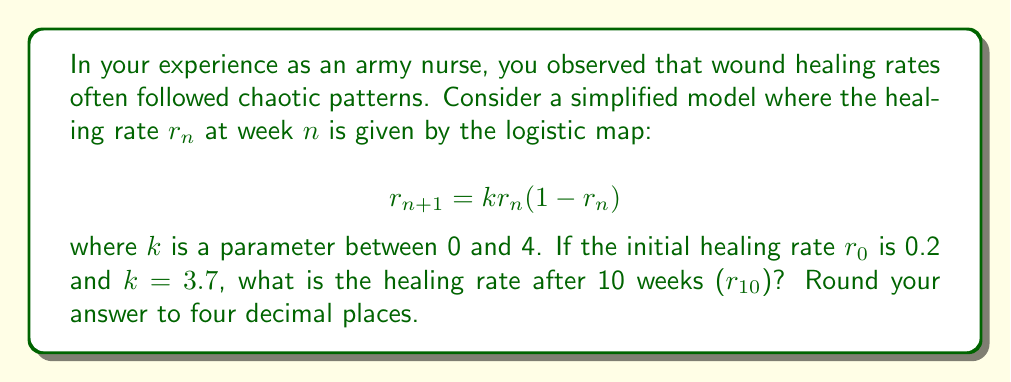Can you answer this question? To solve this problem, we need to iterate the logistic map equation 10 times, starting with $r_0 = 0.2$ and using $k = 3.7$. Let's calculate step-by-step:

1) $r_1 = 3.7 \cdot 0.2 \cdot (1-0.2) = 0.592$

2) $r_2 = 3.7 \cdot 0.592 \cdot (1-0.592) = 0.8931968$

3) $r_3 = 3.7 \cdot 0.8931968 \cdot (1-0.8931968) = 0.3524599$

4) $r_4 = 3.7 \cdot 0.3524599 \cdot (1-0.3524599) = 0.8431972$

5) $r_5 = 3.7 \cdot 0.8431972 \cdot (1-0.8431972) = 0.4896054$

6) $r_6 = 3.7 \cdot 0.4896054 \cdot (1-0.4896054) = 0.9239432$

7) $r_7 = 3.7 \cdot 0.9239432 \cdot (1-0.9239432) = 0.2597095$

8) $r_8 = 3.7 \cdot 0.2597095 \cdot (1-0.2597095) = 0.7112652$

9) $r_9 = 3.7 \cdot 0.7112652 \cdot (1-0.7112652) = 0.7598571$

10) $r_{10} = 3.7 \cdot 0.7598571 \cdot (1-0.7598571) = 0.6752799$

Rounding to four decimal places, we get 0.6753.
Answer: 0.6753 